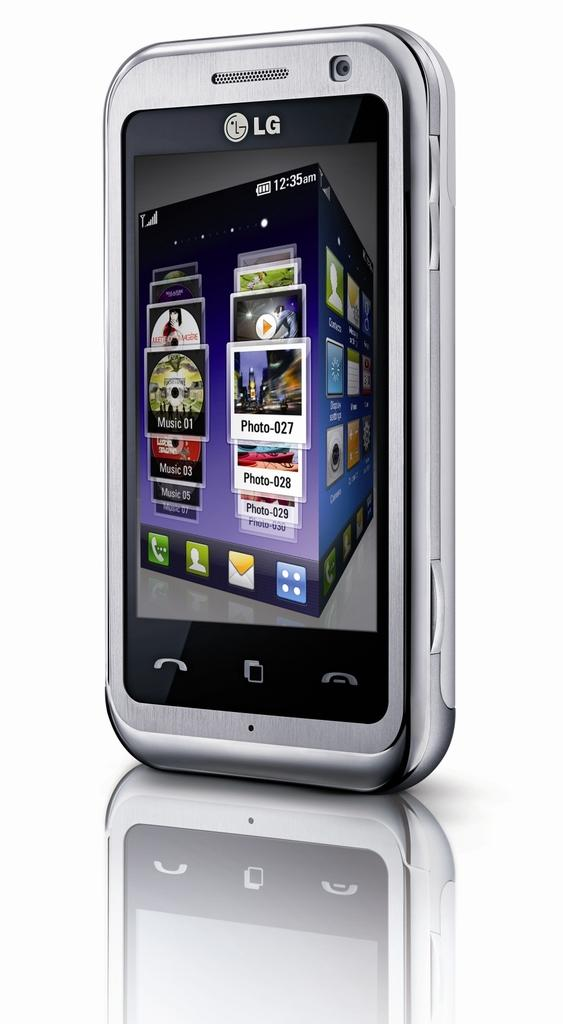Provide a one-sentence caption for the provided image. An LG phone's screen displays Music 01 and Photo-027. 